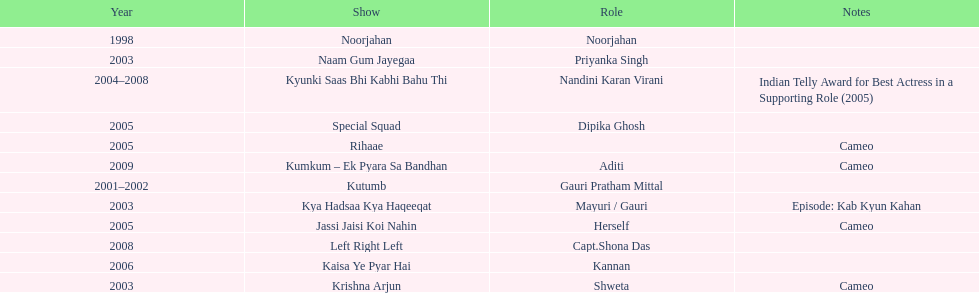In total, how many different tv series has gauri tejwani either starred or cameoed in? 11. 